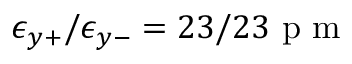<formula> <loc_0><loc_0><loc_500><loc_500>\epsilon _ { y + } / \epsilon _ { y - } = 2 3 / 2 3 p m</formula> 